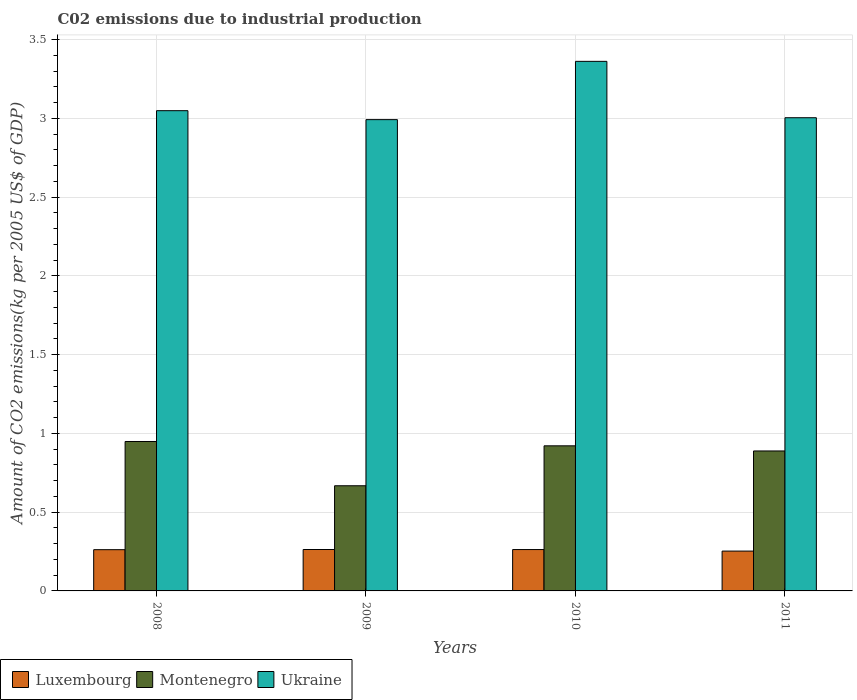How many groups of bars are there?
Give a very brief answer. 4. Are the number of bars on each tick of the X-axis equal?
Your response must be concise. Yes. How many bars are there on the 1st tick from the left?
Your answer should be compact. 3. How many bars are there on the 2nd tick from the right?
Offer a terse response. 3. What is the label of the 1st group of bars from the left?
Your answer should be very brief. 2008. In how many cases, is the number of bars for a given year not equal to the number of legend labels?
Your answer should be compact. 0. What is the amount of CO2 emitted due to industrial production in Luxembourg in 2009?
Your response must be concise. 0.26. Across all years, what is the maximum amount of CO2 emitted due to industrial production in Ukraine?
Make the answer very short. 3.36. Across all years, what is the minimum amount of CO2 emitted due to industrial production in Ukraine?
Ensure brevity in your answer.  2.99. In which year was the amount of CO2 emitted due to industrial production in Montenegro maximum?
Keep it short and to the point. 2008. In which year was the amount of CO2 emitted due to industrial production in Luxembourg minimum?
Provide a succinct answer. 2011. What is the total amount of CO2 emitted due to industrial production in Luxembourg in the graph?
Your answer should be very brief. 1.04. What is the difference between the amount of CO2 emitted due to industrial production in Luxembourg in 2008 and that in 2009?
Provide a short and direct response. -0. What is the difference between the amount of CO2 emitted due to industrial production in Montenegro in 2008 and the amount of CO2 emitted due to industrial production in Ukraine in 2011?
Offer a terse response. -2.06. What is the average amount of CO2 emitted due to industrial production in Luxembourg per year?
Give a very brief answer. 0.26. In the year 2010, what is the difference between the amount of CO2 emitted due to industrial production in Luxembourg and amount of CO2 emitted due to industrial production in Ukraine?
Give a very brief answer. -3.1. What is the ratio of the amount of CO2 emitted due to industrial production in Luxembourg in 2008 to that in 2010?
Your answer should be compact. 1. Is the amount of CO2 emitted due to industrial production in Luxembourg in 2010 less than that in 2011?
Make the answer very short. No. Is the difference between the amount of CO2 emitted due to industrial production in Luxembourg in 2008 and 2010 greater than the difference between the amount of CO2 emitted due to industrial production in Ukraine in 2008 and 2010?
Offer a very short reply. Yes. What is the difference between the highest and the second highest amount of CO2 emitted due to industrial production in Luxembourg?
Provide a short and direct response. 0. What is the difference between the highest and the lowest amount of CO2 emitted due to industrial production in Ukraine?
Your answer should be compact. 0.37. What does the 1st bar from the left in 2008 represents?
Provide a succinct answer. Luxembourg. What does the 3rd bar from the right in 2008 represents?
Give a very brief answer. Luxembourg. How many bars are there?
Your response must be concise. 12. Are all the bars in the graph horizontal?
Your answer should be very brief. No. How many years are there in the graph?
Offer a terse response. 4. What is the difference between two consecutive major ticks on the Y-axis?
Your response must be concise. 0.5. Does the graph contain any zero values?
Keep it short and to the point. No. Does the graph contain grids?
Ensure brevity in your answer.  Yes. Where does the legend appear in the graph?
Ensure brevity in your answer.  Bottom left. How many legend labels are there?
Provide a succinct answer. 3. What is the title of the graph?
Give a very brief answer. C02 emissions due to industrial production. Does "Denmark" appear as one of the legend labels in the graph?
Provide a short and direct response. No. What is the label or title of the X-axis?
Give a very brief answer. Years. What is the label or title of the Y-axis?
Your response must be concise. Amount of CO2 emissions(kg per 2005 US$ of GDP). What is the Amount of CO2 emissions(kg per 2005 US$ of GDP) of Luxembourg in 2008?
Your response must be concise. 0.26. What is the Amount of CO2 emissions(kg per 2005 US$ of GDP) of Montenegro in 2008?
Provide a short and direct response. 0.95. What is the Amount of CO2 emissions(kg per 2005 US$ of GDP) in Ukraine in 2008?
Provide a short and direct response. 3.05. What is the Amount of CO2 emissions(kg per 2005 US$ of GDP) in Luxembourg in 2009?
Offer a terse response. 0.26. What is the Amount of CO2 emissions(kg per 2005 US$ of GDP) of Montenegro in 2009?
Your response must be concise. 0.67. What is the Amount of CO2 emissions(kg per 2005 US$ of GDP) of Ukraine in 2009?
Provide a succinct answer. 2.99. What is the Amount of CO2 emissions(kg per 2005 US$ of GDP) in Luxembourg in 2010?
Your answer should be compact. 0.26. What is the Amount of CO2 emissions(kg per 2005 US$ of GDP) in Montenegro in 2010?
Your answer should be compact. 0.92. What is the Amount of CO2 emissions(kg per 2005 US$ of GDP) in Ukraine in 2010?
Keep it short and to the point. 3.36. What is the Amount of CO2 emissions(kg per 2005 US$ of GDP) in Luxembourg in 2011?
Provide a short and direct response. 0.25. What is the Amount of CO2 emissions(kg per 2005 US$ of GDP) in Montenegro in 2011?
Offer a terse response. 0.89. What is the Amount of CO2 emissions(kg per 2005 US$ of GDP) in Ukraine in 2011?
Make the answer very short. 3. Across all years, what is the maximum Amount of CO2 emissions(kg per 2005 US$ of GDP) in Luxembourg?
Your answer should be very brief. 0.26. Across all years, what is the maximum Amount of CO2 emissions(kg per 2005 US$ of GDP) in Montenegro?
Ensure brevity in your answer.  0.95. Across all years, what is the maximum Amount of CO2 emissions(kg per 2005 US$ of GDP) of Ukraine?
Give a very brief answer. 3.36. Across all years, what is the minimum Amount of CO2 emissions(kg per 2005 US$ of GDP) of Luxembourg?
Give a very brief answer. 0.25. Across all years, what is the minimum Amount of CO2 emissions(kg per 2005 US$ of GDP) of Montenegro?
Make the answer very short. 0.67. Across all years, what is the minimum Amount of CO2 emissions(kg per 2005 US$ of GDP) of Ukraine?
Your answer should be very brief. 2.99. What is the total Amount of CO2 emissions(kg per 2005 US$ of GDP) in Luxembourg in the graph?
Your answer should be very brief. 1.04. What is the total Amount of CO2 emissions(kg per 2005 US$ of GDP) of Montenegro in the graph?
Offer a terse response. 3.43. What is the total Amount of CO2 emissions(kg per 2005 US$ of GDP) in Ukraine in the graph?
Your answer should be compact. 12.41. What is the difference between the Amount of CO2 emissions(kg per 2005 US$ of GDP) of Luxembourg in 2008 and that in 2009?
Your answer should be very brief. -0. What is the difference between the Amount of CO2 emissions(kg per 2005 US$ of GDP) of Montenegro in 2008 and that in 2009?
Provide a succinct answer. 0.28. What is the difference between the Amount of CO2 emissions(kg per 2005 US$ of GDP) in Ukraine in 2008 and that in 2009?
Keep it short and to the point. 0.06. What is the difference between the Amount of CO2 emissions(kg per 2005 US$ of GDP) of Luxembourg in 2008 and that in 2010?
Your response must be concise. -0. What is the difference between the Amount of CO2 emissions(kg per 2005 US$ of GDP) of Montenegro in 2008 and that in 2010?
Ensure brevity in your answer.  0.03. What is the difference between the Amount of CO2 emissions(kg per 2005 US$ of GDP) of Ukraine in 2008 and that in 2010?
Offer a very short reply. -0.31. What is the difference between the Amount of CO2 emissions(kg per 2005 US$ of GDP) of Luxembourg in 2008 and that in 2011?
Your response must be concise. 0.01. What is the difference between the Amount of CO2 emissions(kg per 2005 US$ of GDP) in Montenegro in 2008 and that in 2011?
Make the answer very short. 0.06. What is the difference between the Amount of CO2 emissions(kg per 2005 US$ of GDP) in Ukraine in 2008 and that in 2011?
Give a very brief answer. 0.04. What is the difference between the Amount of CO2 emissions(kg per 2005 US$ of GDP) in Luxembourg in 2009 and that in 2010?
Offer a terse response. 0. What is the difference between the Amount of CO2 emissions(kg per 2005 US$ of GDP) of Montenegro in 2009 and that in 2010?
Offer a very short reply. -0.25. What is the difference between the Amount of CO2 emissions(kg per 2005 US$ of GDP) in Ukraine in 2009 and that in 2010?
Make the answer very short. -0.37. What is the difference between the Amount of CO2 emissions(kg per 2005 US$ of GDP) in Luxembourg in 2009 and that in 2011?
Keep it short and to the point. 0.01. What is the difference between the Amount of CO2 emissions(kg per 2005 US$ of GDP) of Montenegro in 2009 and that in 2011?
Provide a succinct answer. -0.22. What is the difference between the Amount of CO2 emissions(kg per 2005 US$ of GDP) of Ukraine in 2009 and that in 2011?
Ensure brevity in your answer.  -0.01. What is the difference between the Amount of CO2 emissions(kg per 2005 US$ of GDP) in Luxembourg in 2010 and that in 2011?
Provide a succinct answer. 0.01. What is the difference between the Amount of CO2 emissions(kg per 2005 US$ of GDP) of Montenegro in 2010 and that in 2011?
Your answer should be compact. 0.03. What is the difference between the Amount of CO2 emissions(kg per 2005 US$ of GDP) in Ukraine in 2010 and that in 2011?
Offer a very short reply. 0.36. What is the difference between the Amount of CO2 emissions(kg per 2005 US$ of GDP) in Luxembourg in 2008 and the Amount of CO2 emissions(kg per 2005 US$ of GDP) in Montenegro in 2009?
Offer a terse response. -0.41. What is the difference between the Amount of CO2 emissions(kg per 2005 US$ of GDP) of Luxembourg in 2008 and the Amount of CO2 emissions(kg per 2005 US$ of GDP) of Ukraine in 2009?
Make the answer very short. -2.73. What is the difference between the Amount of CO2 emissions(kg per 2005 US$ of GDP) in Montenegro in 2008 and the Amount of CO2 emissions(kg per 2005 US$ of GDP) in Ukraine in 2009?
Ensure brevity in your answer.  -2.04. What is the difference between the Amount of CO2 emissions(kg per 2005 US$ of GDP) of Luxembourg in 2008 and the Amount of CO2 emissions(kg per 2005 US$ of GDP) of Montenegro in 2010?
Provide a succinct answer. -0.66. What is the difference between the Amount of CO2 emissions(kg per 2005 US$ of GDP) in Luxembourg in 2008 and the Amount of CO2 emissions(kg per 2005 US$ of GDP) in Ukraine in 2010?
Provide a short and direct response. -3.1. What is the difference between the Amount of CO2 emissions(kg per 2005 US$ of GDP) in Montenegro in 2008 and the Amount of CO2 emissions(kg per 2005 US$ of GDP) in Ukraine in 2010?
Your answer should be very brief. -2.41. What is the difference between the Amount of CO2 emissions(kg per 2005 US$ of GDP) in Luxembourg in 2008 and the Amount of CO2 emissions(kg per 2005 US$ of GDP) in Montenegro in 2011?
Offer a very short reply. -0.63. What is the difference between the Amount of CO2 emissions(kg per 2005 US$ of GDP) in Luxembourg in 2008 and the Amount of CO2 emissions(kg per 2005 US$ of GDP) in Ukraine in 2011?
Your answer should be compact. -2.74. What is the difference between the Amount of CO2 emissions(kg per 2005 US$ of GDP) of Montenegro in 2008 and the Amount of CO2 emissions(kg per 2005 US$ of GDP) of Ukraine in 2011?
Provide a succinct answer. -2.06. What is the difference between the Amount of CO2 emissions(kg per 2005 US$ of GDP) in Luxembourg in 2009 and the Amount of CO2 emissions(kg per 2005 US$ of GDP) in Montenegro in 2010?
Your response must be concise. -0.66. What is the difference between the Amount of CO2 emissions(kg per 2005 US$ of GDP) in Luxembourg in 2009 and the Amount of CO2 emissions(kg per 2005 US$ of GDP) in Ukraine in 2010?
Your response must be concise. -3.1. What is the difference between the Amount of CO2 emissions(kg per 2005 US$ of GDP) in Montenegro in 2009 and the Amount of CO2 emissions(kg per 2005 US$ of GDP) in Ukraine in 2010?
Your answer should be very brief. -2.69. What is the difference between the Amount of CO2 emissions(kg per 2005 US$ of GDP) of Luxembourg in 2009 and the Amount of CO2 emissions(kg per 2005 US$ of GDP) of Montenegro in 2011?
Your answer should be compact. -0.63. What is the difference between the Amount of CO2 emissions(kg per 2005 US$ of GDP) of Luxembourg in 2009 and the Amount of CO2 emissions(kg per 2005 US$ of GDP) of Ukraine in 2011?
Ensure brevity in your answer.  -2.74. What is the difference between the Amount of CO2 emissions(kg per 2005 US$ of GDP) of Montenegro in 2009 and the Amount of CO2 emissions(kg per 2005 US$ of GDP) of Ukraine in 2011?
Make the answer very short. -2.34. What is the difference between the Amount of CO2 emissions(kg per 2005 US$ of GDP) in Luxembourg in 2010 and the Amount of CO2 emissions(kg per 2005 US$ of GDP) in Montenegro in 2011?
Your answer should be very brief. -0.63. What is the difference between the Amount of CO2 emissions(kg per 2005 US$ of GDP) of Luxembourg in 2010 and the Amount of CO2 emissions(kg per 2005 US$ of GDP) of Ukraine in 2011?
Ensure brevity in your answer.  -2.74. What is the difference between the Amount of CO2 emissions(kg per 2005 US$ of GDP) in Montenegro in 2010 and the Amount of CO2 emissions(kg per 2005 US$ of GDP) in Ukraine in 2011?
Give a very brief answer. -2.08. What is the average Amount of CO2 emissions(kg per 2005 US$ of GDP) of Luxembourg per year?
Provide a succinct answer. 0.26. What is the average Amount of CO2 emissions(kg per 2005 US$ of GDP) in Montenegro per year?
Your answer should be compact. 0.86. What is the average Amount of CO2 emissions(kg per 2005 US$ of GDP) of Ukraine per year?
Offer a very short reply. 3.1. In the year 2008, what is the difference between the Amount of CO2 emissions(kg per 2005 US$ of GDP) of Luxembourg and Amount of CO2 emissions(kg per 2005 US$ of GDP) of Montenegro?
Offer a terse response. -0.69. In the year 2008, what is the difference between the Amount of CO2 emissions(kg per 2005 US$ of GDP) of Luxembourg and Amount of CO2 emissions(kg per 2005 US$ of GDP) of Ukraine?
Provide a short and direct response. -2.79. In the year 2008, what is the difference between the Amount of CO2 emissions(kg per 2005 US$ of GDP) of Montenegro and Amount of CO2 emissions(kg per 2005 US$ of GDP) of Ukraine?
Offer a very short reply. -2.1. In the year 2009, what is the difference between the Amount of CO2 emissions(kg per 2005 US$ of GDP) of Luxembourg and Amount of CO2 emissions(kg per 2005 US$ of GDP) of Montenegro?
Offer a terse response. -0.4. In the year 2009, what is the difference between the Amount of CO2 emissions(kg per 2005 US$ of GDP) of Luxembourg and Amount of CO2 emissions(kg per 2005 US$ of GDP) of Ukraine?
Your answer should be very brief. -2.73. In the year 2009, what is the difference between the Amount of CO2 emissions(kg per 2005 US$ of GDP) in Montenegro and Amount of CO2 emissions(kg per 2005 US$ of GDP) in Ukraine?
Offer a terse response. -2.32. In the year 2010, what is the difference between the Amount of CO2 emissions(kg per 2005 US$ of GDP) of Luxembourg and Amount of CO2 emissions(kg per 2005 US$ of GDP) of Montenegro?
Ensure brevity in your answer.  -0.66. In the year 2010, what is the difference between the Amount of CO2 emissions(kg per 2005 US$ of GDP) in Luxembourg and Amount of CO2 emissions(kg per 2005 US$ of GDP) in Ukraine?
Provide a succinct answer. -3.1. In the year 2010, what is the difference between the Amount of CO2 emissions(kg per 2005 US$ of GDP) of Montenegro and Amount of CO2 emissions(kg per 2005 US$ of GDP) of Ukraine?
Your response must be concise. -2.44. In the year 2011, what is the difference between the Amount of CO2 emissions(kg per 2005 US$ of GDP) of Luxembourg and Amount of CO2 emissions(kg per 2005 US$ of GDP) of Montenegro?
Offer a terse response. -0.64. In the year 2011, what is the difference between the Amount of CO2 emissions(kg per 2005 US$ of GDP) in Luxembourg and Amount of CO2 emissions(kg per 2005 US$ of GDP) in Ukraine?
Offer a very short reply. -2.75. In the year 2011, what is the difference between the Amount of CO2 emissions(kg per 2005 US$ of GDP) in Montenegro and Amount of CO2 emissions(kg per 2005 US$ of GDP) in Ukraine?
Offer a terse response. -2.12. What is the ratio of the Amount of CO2 emissions(kg per 2005 US$ of GDP) of Montenegro in 2008 to that in 2009?
Your response must be concise. 1.42. What is the ratio of the Amount of CO2 emissions(kg per 2005 US$ of GDP) of Ukraine in 2008 to that in 2009?
Provide a short and direct response. 1.02. What is the ratio of the Amount of CO2 emissions(kg per 2005 US$ of GDP) in Luxembourg in 2008 to that in 2010?
Your response must be concise. 1. What is the ratio of the Amount of CO2 emissions(kg per 2005 US$ of GDP) in Montenegro in 2008 to that in 2010?
Provide a short and direct response. 1.03. What is the ratio of the Amount of CO2 emissions(kg per 2005 US$ of GDP) of Ukraine in 2008 to that in 2010?
Provide a short and direct response. 0.91. What is the ratio of the Amount of CO2 emissions(kg per 2005 US$ of GDP) of Luxembourg in 2008 to that in 2011?
Provide a short and direct response. 1.04. What is the ratio of the Amount of CO2 emissions(kg per 2005 US$ of GDP) of Montenegro in 2008 to that in 2011?
Ensure brevity in your answer.  1.07. What is the ratio of the Amount of CO2 emissions(kg per 2005 US$ of GDP) of Ukraine in 2008 to that in 2011?
Offer a terse response. 1.01. What is the ratio of the Amount of CO2 emissions(kg per 2005 US$ of GDP) in Montenegro in 2009 to that in 2010?
Provide a succinct answer. 0.72. What is the ratio of the Amount of CO2 emissions(kg per 2005 US$ of GDP) in Ukraine in 2009 to that in 2010?
Ensure brevity in your answer.  0.89. What is the ratio of the Amount of CO2 emissions(kg per 2005 US$ of GDP) in Luxembourg in 2009 to that in 2011?
Your answer should be compact. 1.04. What is the ratio of the Amount of CO2 emissions(kg per 2005 US$ of GDP) in Montenegro in 2009 to that in 2011?
Your response must be concise. 0.75. What is the ratio of the Amount of CO2 emissions(kg per 2005 US$ of GDP) of Montenegro in 2010 to that in 2011?
Keep it short and to the point. 1.04. What is the ratio of the Amount of CO2 emissions(kg per 2005 US$ of GDP) in Ukraine in 2010 to that in 2011?
Provide a short and direct response. 1.12. What is the difference between the highest and the second highest Amount of CO2 emissions(kg per 2005 US$ of GDP) of Montenegro?
Ensure brevity in your answer.  0.03. What is the difference between the highest and the second highest Amount of CO2 emissions(kg per 2005 US$ of GDP) in Ukraine?
Make the answer very short. 0.31. What is the difference between the highest and the lowest Amount of CO2 emissions(kg per 2005 US$ of GDP) in Luxembourg?
Your answer should be very brief. 0.01. What is the difference between the highest and the lowest Amount of CO2 emissions(kg per 2005 US$ of GDP) of Montenegro?
Give a very brief answer. 0.28. What is the difference between the highest and the lowest Amount of CO2 emissions(kg per 2005 US$ of GDP) of Ukraine?
Your response must be concise. 0.37. 